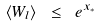Convert formula to latex. <formula><loc_0><loc_0><loc_500><loc_500>\langle W _ { l } \rangle \ \leq \ e ^ { x _ { * } }</formula> 